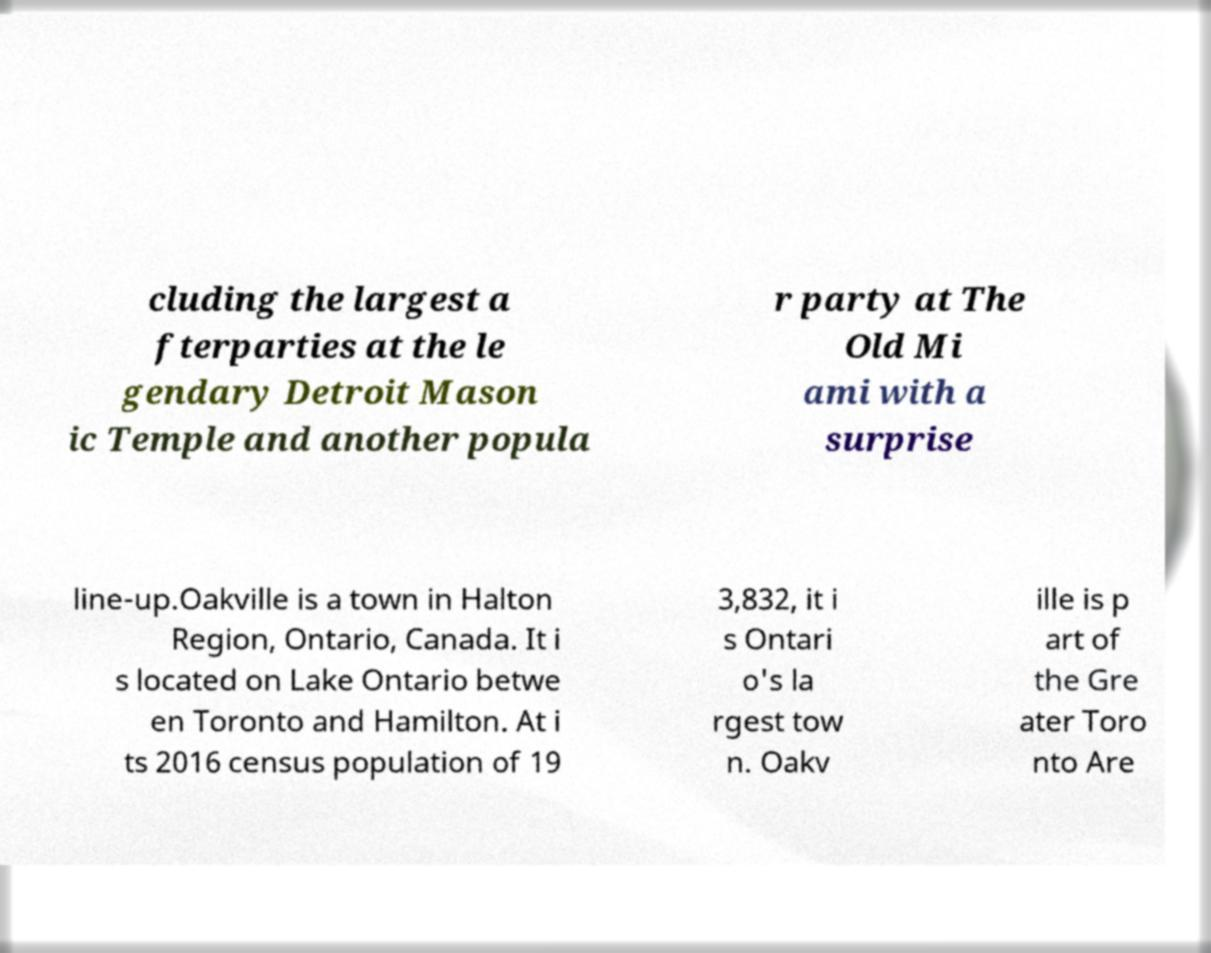Can you accurately transcribe the text from the provided image for me? cluding the largest a fterparties at the le gendary Detroit Mason ic Temple and another popula r party at The Old Mi ami with a surprise line-up.Oakville is a town in Halton Region, Ontario, Canada. It i s located on Lake Ontario betwe en Toronto and Hamilton. At i ts 2016 census population of 19 3,832, it i s Ontari o's la rgest tow n. Oakv ille is p art of the Gre ater Toro nto Are 